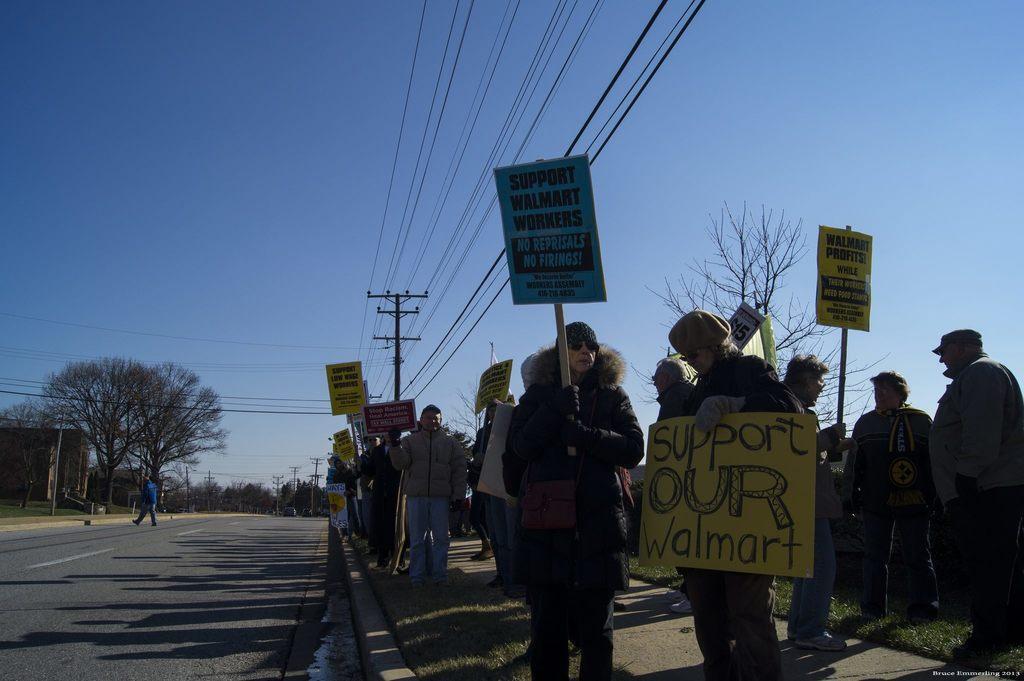How would you summarize this image in a sentence or two? There are group of people standing where few of them are holding some boards which has something written on it in the right corner and there are trees,poles and wires in the background. 